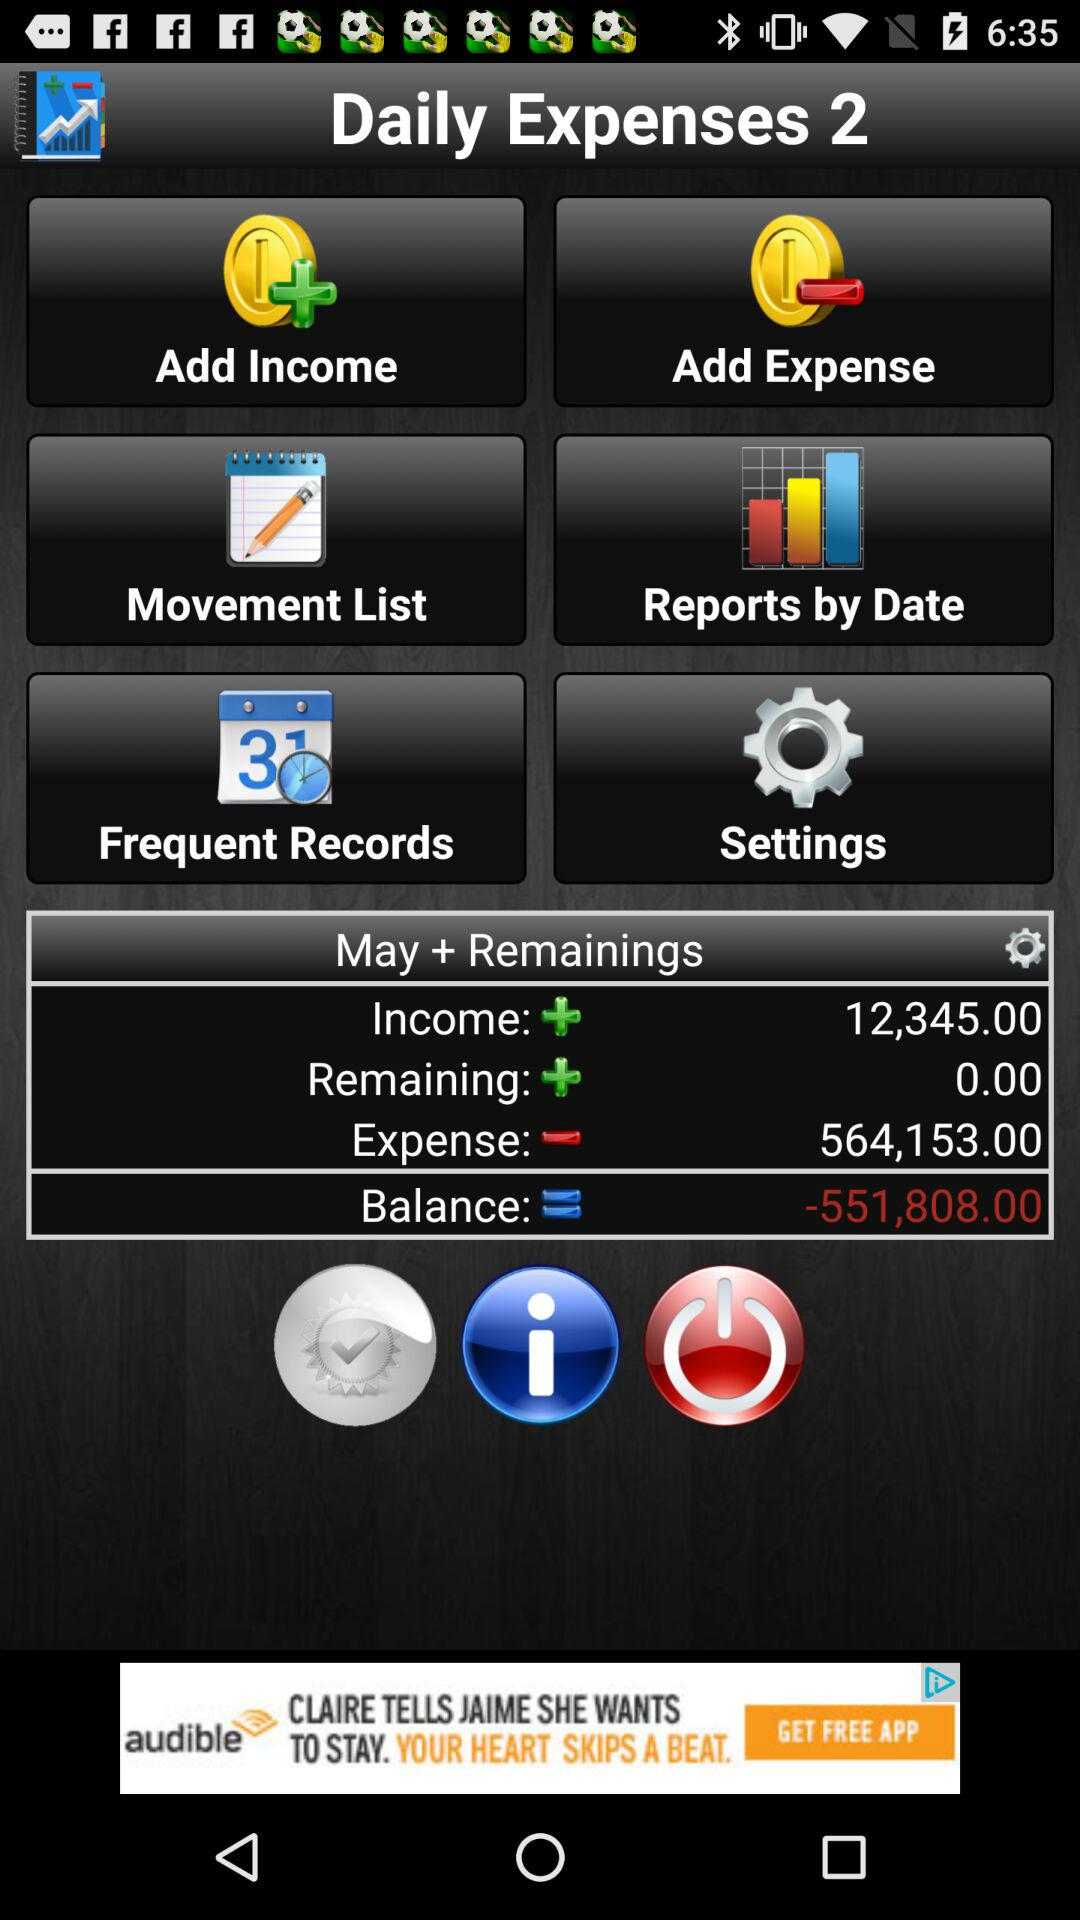How much more money did I spend than I earned this month?
Answer the question using a single word or phrase. -551,808.00 